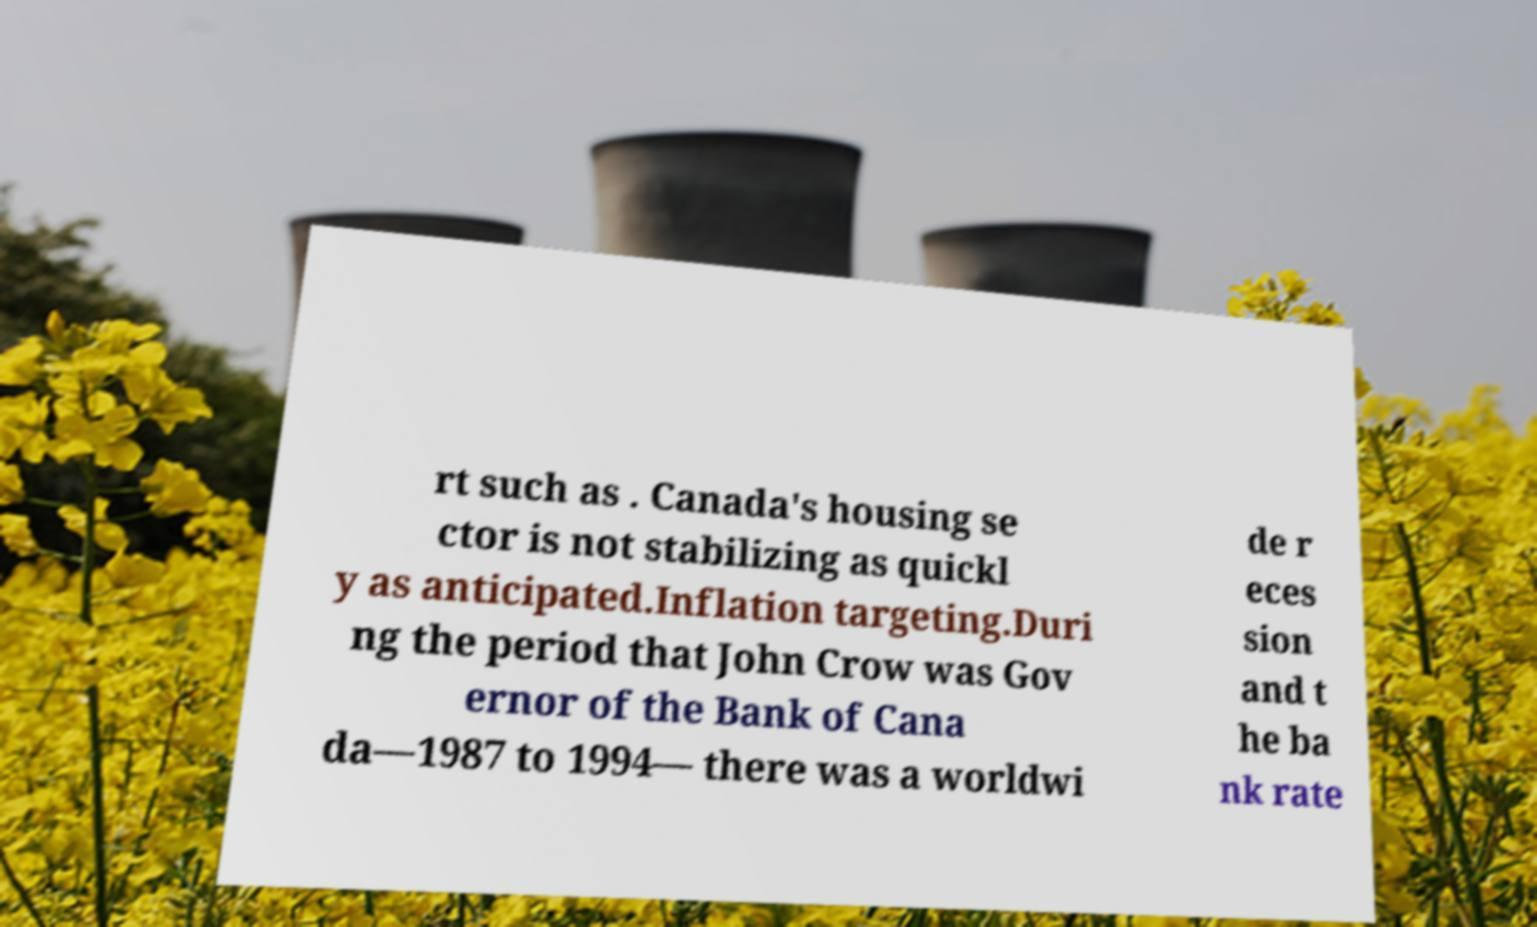Can you accurately transcribe the text from the provided image for me? rt such as . Canada's housing se ctor is not stabilizing as quickl y as anticipated.Inflation targeting.Duri ng the period that John Crow was Gov ernor of the Bank of Cana da—1987 to 1994— there was a worldwi de r eces sion and t he ba nk rate 